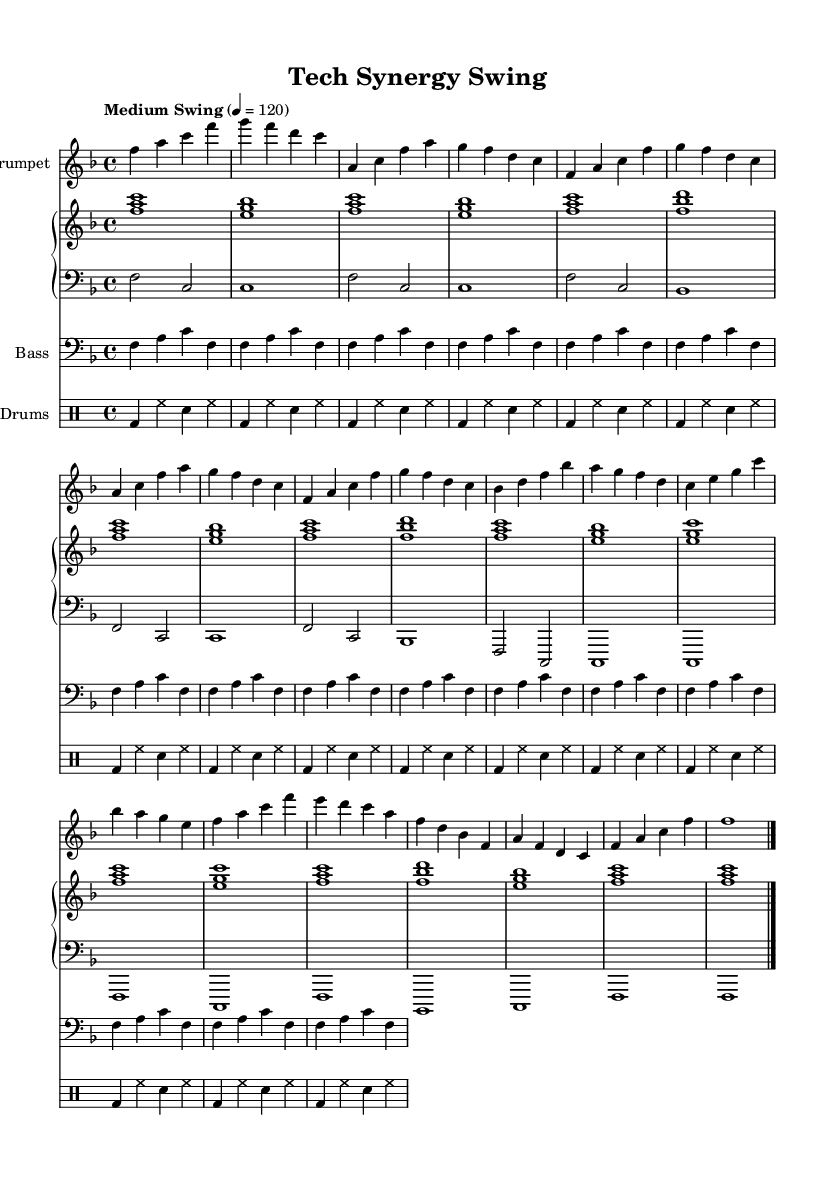What is the key signature of this music? The key signature at the beginning indicates that the piece is in F major, which has one flat (B flat).
Answer: F major What is the time signature of this music? The time signature displayed at the beginning is 4/4, indicating four beats in each measure.
Answer: 4/4 What is the tempo marking for this piece? The tempo marking is indicated as "Medium Swing" with a metronome marking of 4 = 120. This indicates a moderate swinging tempo.
Answer: Medium Swing 4 = 120 How many measures are in the A section of the piece? Counting the measures in the A section shows a total of eight measures, based on the repeated structure and lines in the music.
Answer: 8 measures What is the primary style of this piece? The piece is labeled as "swing" and is structured with standard jazz elements like a walking bass and swing rhythm.
Answer: Swing What instrument has the main melody? The trumpet is indicated as the primary instrument carrying the main melody throughout the piece.
Answer: Trumpet What rhythmic pattern is used by the drums? The drum part uses a basic swing pattern consisting of bass drum, hi-hat, and snare drum in a four-beat pattern.
Answer: Swing pattern 